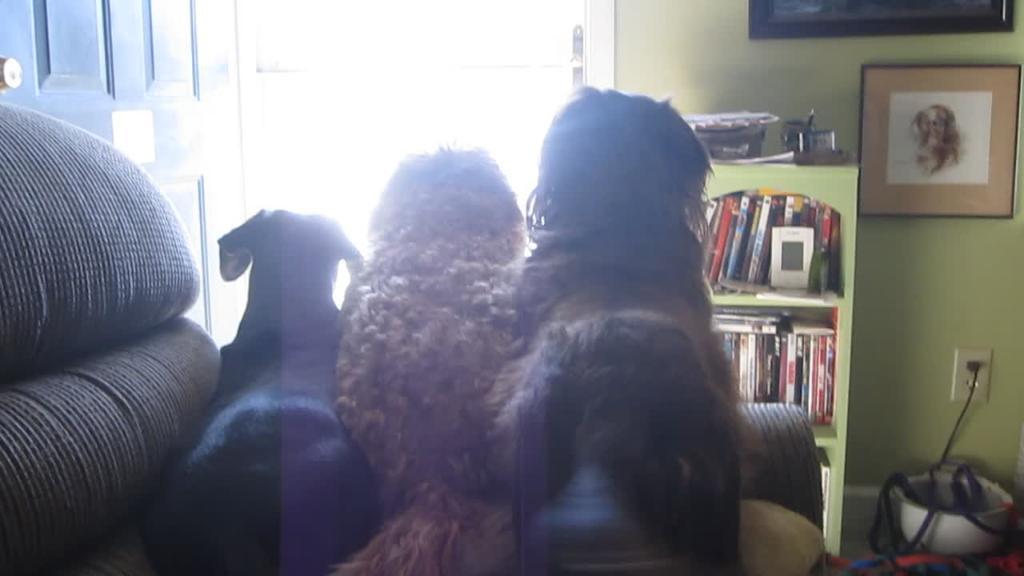Can you describe this image briefly? In this image there are three dogs on a sofa,in front of them there is a door, a books rack, a photo frame on the wall and other object on the floor. 